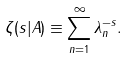<formula> <loc_0><loc_0><loc_500><loc_500>\zeta ( s | A ) \equiv \sum _ { n = 1 } ^ { \infty } \lambda _ { n } ^ { - s } .</formula> 